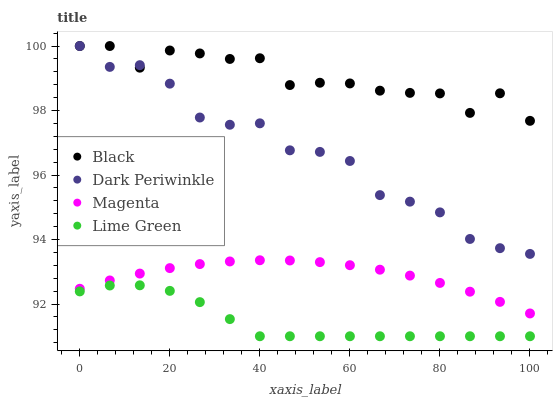Does Lime Green have the minimum area under the curve?
Answer yes or no. Yes. Does Black have the maximum area under the curve?
Answer yes or no. Yes. Does Magenta have the minimum area under the curve?
Answer yes or no. No. Does Magenta have the maximum area under the curve?
Answer yes or no. No. Is Magenta the smoothest?
Answer yes or no. Yes. Is Black the roughest?
Answer yes or no. Yes. Is Black the smoothest?
Answer yes or no. No. Is Magenta the roughest?
Answer yes or no. No. Does Lime Green have the lowest value?
Answer yes or no. Yes. Does Magenta have the lowest value?
Answer yes or no. No. Does Dark Periwinkle have the highest value?
Answer yes or no. Yes. Does Magenta have the highest value?
Answer yes or no. No. Is Lime Green less than Dark Periwinkle?
Answer yes or no. Yes. Is Magenta greater than Lime Green?
Answer yes or no. Yes. Does Dark Periwinkle intersect Black?
Answer yes or no. Yes. Is Dark Periwinkle less than Black?
Answer yes or no. No. Is Dark Periwinkle greater than Black?
Answer yes or no. No. Does Lime Green intersect Dark Periwinkle?
Answer yes or no. No. 